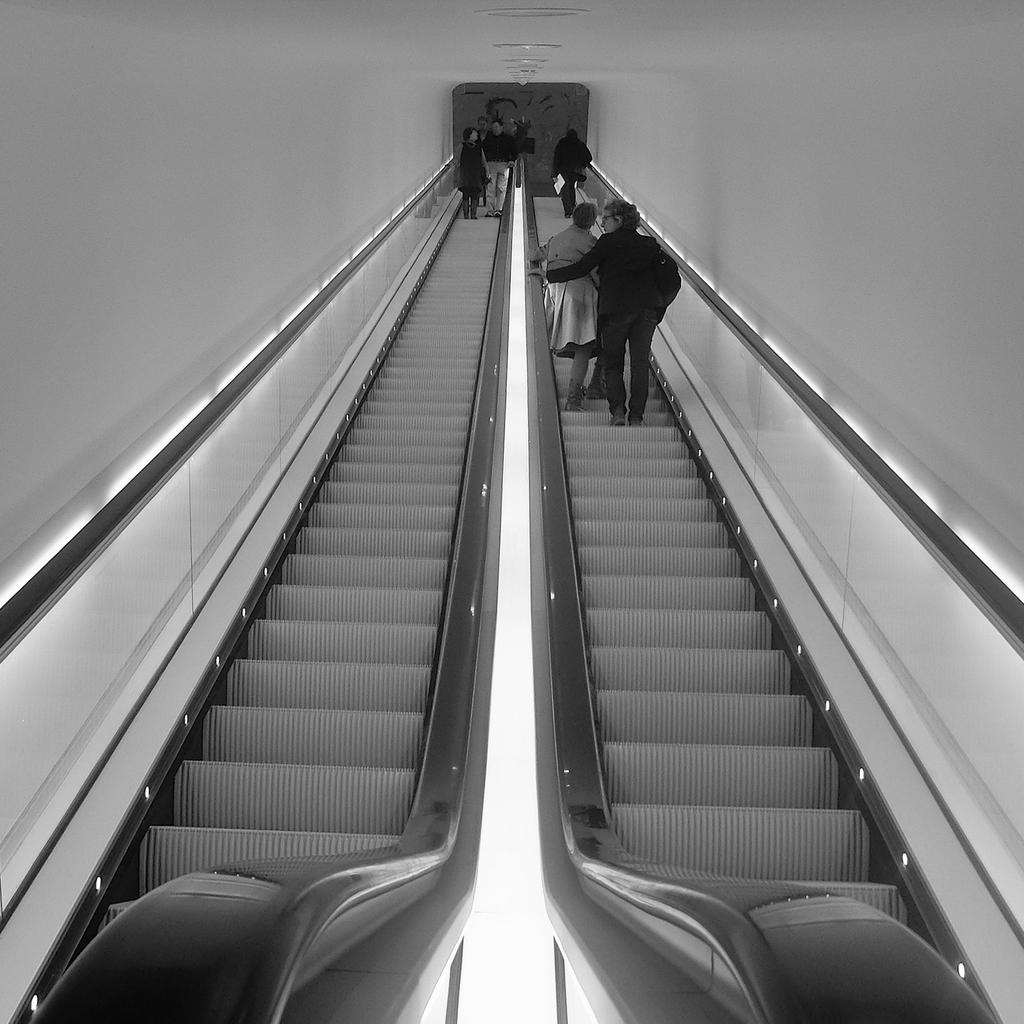What are the people in the image doing? The persons in the image are standing on the escalator. What can be seen on the sides of the escalator? There is a wall at the sides of the escalator. What is located in front of the escalator? There is an object in front of the escalator. What type of attraction is being advertised on the wall next to the escalator? There is no attraction being advertised on the wall next to the escalator in the image. Is there any evidence of a crime taking place near the escalator? There is no indication of a crime in the image; it simply shows people standing on an escalator with a wall and an object nearby. 